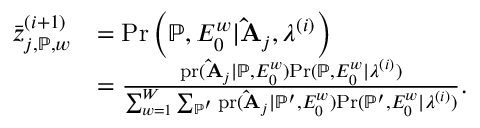Convert formula to latex. <formula><loc_0><loc_0><loc_500><loc_500>\begin{array} { r l } { \bar { z } _ { j , \mathbb { P } , w } ^ { ( i + 1 ) } } & { = P r \left ( \mathbb { P } , E _ { 0 } ^ { w } | \hat { A } _ { j } , \lambda ^ { ( i ) } \right ) } \\ & { = \frac { p r ( \hat { A } _ { j } | \mathbb { P } , E _ { 0 } ^ { w } ) P r ( \mathbb { P } , E _ { 0 } ^ { w } | \lambda ^ { ( i ) } ) } { \sum _ { w = 1 } ^ { W } \sum _ { \mathbb { P } ^ { \prime } } p r ( \hat { A } _ { j } | \mathbb { P } ^ { \prime } , E _ { 0 } ^ { w } ) P r ( \mathbb { P } ^ { \prime } , E _ { 0 } ^ { w } | \lambda ^ { ( i ) } ) } . } \end{array}</formula> 